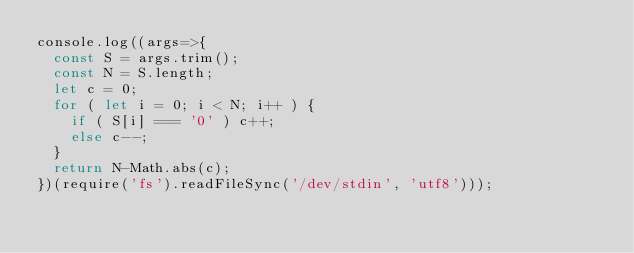<code> <loc_0><loc_0><loc_500><loc_500><_JavaScript_>console.log((args=>{
  const S = args.trim();
  const N = S.length;
  let c = 0;
  for ( let i = 0; i < N; i++ ) {
    if ( S[i] === '0' ) c++;
    else c--;
  }
  return N-Math.abs(c);
})(require('fs').readFileSync('/dev/stdin', 'utf8')));
</code> 